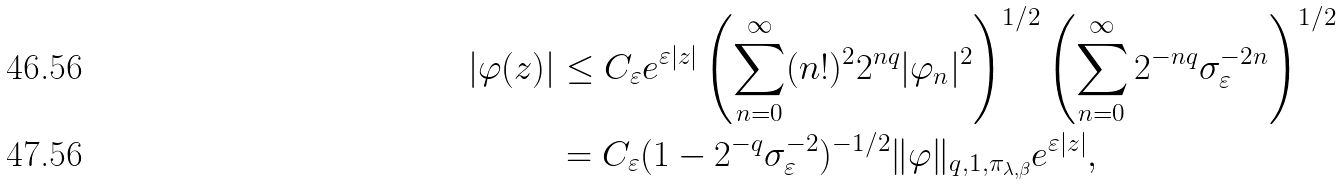Convert formula to latex. <formula><loc_0><loc_0><loc_500><loc_500>| \varphi ( z ) | & \leq C _ { \varepsilon } e ^ { \varepsilon | z | } \left ( \sum _ { n = 0 } ^ { \infty } ( n ! ) ^ { 2 } 2 ^ { n q } | \varphi _ { n } | ^ { 2 } \right ) ^ { 1 / 2 } \left ( \sum _ { n = 0 } ^ { \infty } 2 ^ { - n q } \sigma _ { \varepsilon } ^ { - 2 n } \right ) ^ { 1 / 2 } \\ & = C _ { \varepsilon } ( 1 - 2 ^ { - q } \sigma _ { \varepsilon } ^ { - 2 } ) ^ { - 1 / 2 } \| \varphi \| _ { q , 1 , \pi _ { \lambda , \beta } } e ^ { \varepsilon | z | } ,</formula> 